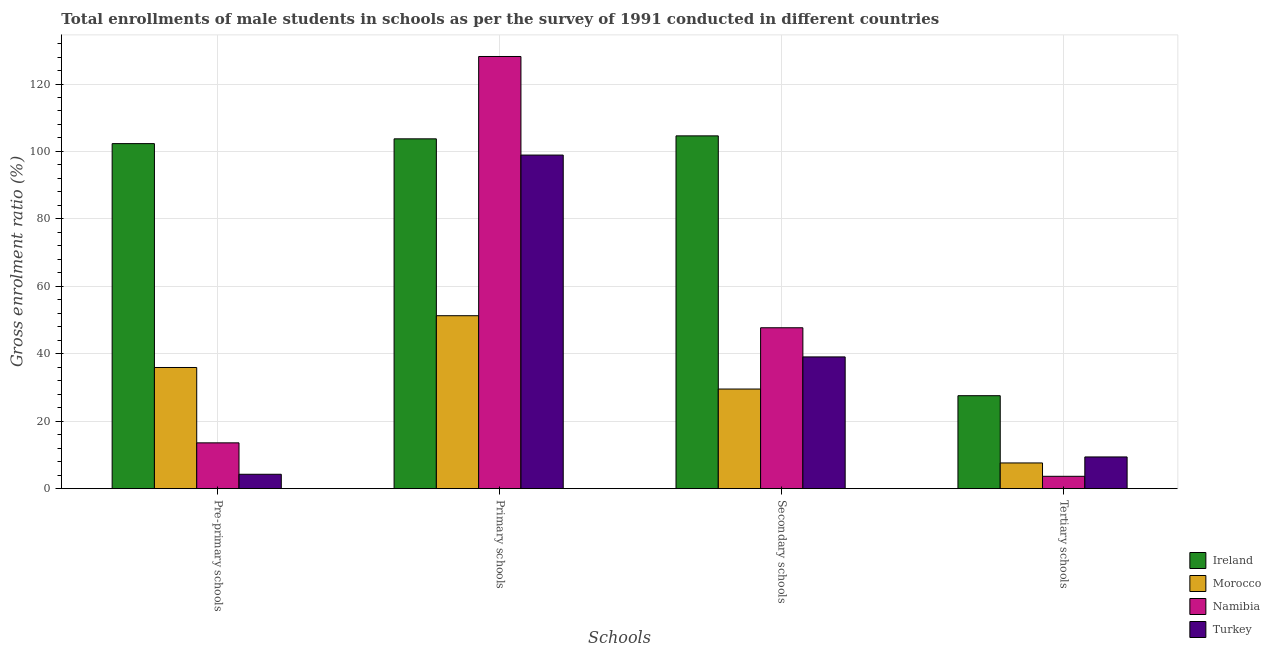How many groups of bars are there?
Your answer should be compact. 4. Are the number of bars per tick equal to the number of legend labels?
Provide a succinct answer. Yes. Are the number of bars on each tick of the X-axis equal?
Provide a succinct answer. Yes. How many bars are there on the 4th tick from the left?
Offer a very short reply. 4. How many bars are there on the 1st tick from the right?
Give a very brief answer. 4. What is the label of the 1st group of bars from the left?
Your response must be concise. Pre-primary schools. What is the gross enrolment ratio(male) in primary schools in Morocco?
Offer a terse response. 51.29. Across all countries, what is the maximum gross enrolment ratio(male) in tertiary schools?
Your response must be concise. 27.57. Across all countries, what is the minimum gross enrolment ratio(male) in secondary schools?
Give a very brief answer. 29.54. In which country was the gross enrolment ratio(male) in secondary schools maximum?
Offer a terse response. Ireland. In which country was the gross enrolment ratio(male) in tertiary schools minimum?
Provide a short and direct response. Namibia. What is the total gross enrolment ratio(male) in primary schools in the graph?
Offer a very short reply. 382.12. What is the difference between the gross enrolment ratio(male) in secondary schools in Morocco and that in Turkey?
Provide a succinct answer. -9.53. What is the difference between the gross enrolment ratio(male) in primary schools in Namibia and the gross enrolment ratio(male) in pre-primary schools in Turkey?
Your response must be concise. 123.89. What is the average gross enrolment ratio(male) in primary schools per country?
Ensure brevity in your answer.  95.53. What is the difference between the gross enrolment ratio(male) in pre-primary schools and gross enrolment ratio(male) in primary schools in Turkey?
Provide a succinct answer. -94.66. What is the ratio of the gross enrolment ratio(male) in tertiary schools in Namibia to that in Turkey?
Your answer should be compact. 0.39. Is the gross enrolment ratio(male) in tertiary schools in Namibia less than that in Ireland?
Your answer should be very brief. Yes. What is the difference between the highest and the second highest gross enrolment ratio(male) in tertiary schools?
Your answer should be compact. 18.16. What is the difference between the highest and the lowest gross enrolment ratio(male) in pre-primary schools?
Give a very brief answer. 98.05. What does the 1st bar from the left in Secondary schools represents?
Provide a succinct answer. Ireland. Is it the case that in every country, the sum of the gross enrolment ratio(male) in pre-primary schools and gross enrolment ratio(male) in primary schools is greater than the gross enrolment ratio(male) in secondary schools?
Your answer should be very brief. Yes. How many bars are there?
Offer a terse response. 16. Are all the bars in the graph horizontal?
Keep it short and to the point. No. How many countries are there in the graph?
Provide a short and direct response. 4. What is the difference between two consecutive major ticks on the Y-axis?
Keep it short and to the point. 20. Are the values on the major ticks of Y-axis written in scientific E-notation?
Offer a terse response. No. Does the graph contain any zero values?
Your answer should be very brief. No. Where does the legend appear in the graph?
Ensure brevity in your answer.  Bottom right. How are the legend labels stacked?
Your answer should be compact. Vertical. What is the title of the graph?
Provide a succinct answer. Total enrollments of male students in schools as per the survey of 1991 conducted in different countries. What is the label or title of the X-axis?
Your answer should be very brief. Schools. What is the Gross enrolment ratio (%) in Ireland in Pre-primary schools?
Offer a terse response. 102.32. What is the Gross enrolment ratio (%) in Morocco in Pre-primary schools?
Provide a succinct answer. 35.94. What is the Gross enrolment ratio (%) of Namibia in Pre-primary schools?
Give a very brief answer. 13.59. What is the Gross enrolment ratio (%) of Turkey in Pre-primary schools?
Provide a succinct answer. 4.27. What is the Gross enrolment ratio (%) in Ireland in Primary schools?
Provide a short and direct response. 103.74. What is the Gross enrolment ratio (%) of Morocco in Primary schools?
Offer a terse response. 51.29. What is the Gross enrolment ratio (%) in Namibia in Primary schools?
Provide a short and direct response. 128.16. What is the Gross enrolment ratio (%) in Turkey in Primary schools?
Provide a succinct answer. 98.93. What is the Gross enrolment ratio (%) of Ireland in Secondary schools?
Give a very brief answer. 104.62. What is the Gross enrolment ratio (%) of Morocco in Secondary schools?
Your answer should be very brief. 29.54. What is the Gross enrolment ratio (%) of Namibia in Secondary schools?
Keep it short and to the point. 47.72. What is the Gross enrolment ratio (%) in Turkey in Secondary schools?
Offer a very short reply. 39.07. What is the Gross enrolment ratio (%) in Ireland in Tertiary schools?
Offer a terse response. 27.57. What is the Gross enrolment ratio (%) in Morocco in Tertiary schools?
Give a very brief answer. 7.63. What is the Gross enrolment ratio (%) of Namibia in Tertiary schools?
Offer a very short reply. 3.67. What is the Gross enrolment ratio (%) of Turkey in Tertiary schools?
Provide a succinct answer. 9.41. Across all Schools, what is the maximum Gross enrolment ratio (%) in Ireland?
Offer a terse response. 104.62. Across all Schools, what is the maximum Gross enrolment ratio (%) in Morocco?
Ensure brevity in your answer.  51.29. Across all Schools, what is the maximum Gross enrolment ratio (%) in Namibia?
Give a very brief answer. 128.16. Across all Schools, what is the maximum Gross enrolment ratio (%) of Turkey?
Your response must be concise. 98.93. Across all Schools, what is the minimum Gross enrolment ratio (%) in Ireland?
Your answer should be very brief. 27.57. Across all Schools, what is the minimum Gross enrolment ratio (%) in Morocco?
Offer a terse response. 7.63. Across all Schools, what is the minimum Gross enrolment ratio (%) of Namibia?
Give a very brief answer. 3.67. Across all Schools, what is the minimum Gross enrolment ratio (%) in Turkey?
Provide a short and direct response. 4.27. What is the total Gross enrolment ratio (%) of Ireland in the graph?
Make the answer very short. 338.26. What is the total Gross enrolment ratio (%) in Morocco in the graph?
Provide a succinct answer. 124.4. What is the total Gross enrolment ratio (%) in Namibia in the graph?
Keep it short and to the point. 193.14. What is the total Gross enrolment ratio (%) in Turkey in the graph?
Make the answer very short. 151.68. What is the difference between the Gross enrolment ratio (%) of Ireland in Pre-primary schools and that in Primary schools?
Your answer should be very brief. -1.42. What is the difference between the Gross enrolment ratio (%) in Morocco in Pre-primary schools and that in Primary schools?
Give a very brief answer. -15.35. What is the difference between the Gross enrolment ratio (%) of Namibia in Pre-primary schools and that in Primary schools?
Give a very brief answer. -114.58. What is the difference between the Gross enrolment ratio (%) of Turkey in Pre-primary schools and that in Primary schools?
Your answer should be compact. -94.66. What is the difference between the Gross enrolment ratio (%) of Ireland in Pre-primary schools and that in Secondary schools?
Make the answer very short. -2.3. What is the difference between the Gross enrolment ratio (%) in Morocco in Pre-primary schools and that in Secondary schools?
Offer a very short reply. 6.39. What is the difference between the Gross enrolment ratio (%) in Namibia in Pre-primary schools and that in Secondary schools?
Your answer should be compact. -34.13. What is the difference between the Gross enrolment ratio (%) of Turkey in Pre-primary schools and that in Secondary schools?
Your answer should be very brief. -34.8. What is the difference between the Gross enrolment ratio (%) of Ireland in Pre-primary schools and that in Tertiary schools?
Offer a very short reply. 74.75. What is the difference between the Gross enrolment ratio (%) in Morocco in Pre-primary schools and that in Tertiary schools?
Offer a terse response. 28.31. What is the difference between the Gross enrolment ratio (%) in Namibia in Pre-primary schools and that in Tertiary schools?
Make the answer very short. 9.92. What is the difference between the Gross enrolment ratio (%) in Turkey in Pre-primary schools and that in Tertiary schools?
Your answer should be very brief. -5.14. What is the difference between the Gross enrolment ratio (%) of Ireland in Primary schools and that in Secondary schools?
Make the answer very short. -0.88. What is the difference between the Gross enrolment ratio (%) in Morocco in Primary schools and that in Secondary schools?
Your response must be concise. 21.74. What is the difference between the Gross enrolment ratio (%) in Namibia in Primary schools and that in Secondary schools?
Keep it short and to the point. 80.45. What is the difference between the Gross enrolment ratio (%) in Turkey in Primary schools and that in Secondary schools?
Make the answer very short. 59.85. What is the difference between the Gross enrolment ratio (%) in Ireland in Primary schools and that in Tertiary schools?
Ensure brevity in your answer.  76.17. What is the difference between the Gross enrolment ratio (%) in Morocco in Primary schools and that in Tertiary schools?
Provide a short and direct response. 43.66. What is the difference between the Gross enrolment ratio (%) of Namibia in Primary schools and that in Tertiary schools?
Give a very brief answer. 124.5. What is the difference between the Gross enrolment ratio (%) of Turkey in Primary schools and that in Tertiary schools?
Provide a short and direct response. 89.52. What is the difference between the Gross enrolment ratio (%) of Ireland in Secondary schools and that in Tertiary schools?
Make the answer very short. 77.05. What is the difference between the Gross enrolment ratio (%) of Morocco in Secondary schools and that in Tertiary schools?
Your answer should be very brief. 21.92. What is the difference between the Gross enrolment ratio (%) of Namibia in Secondary schools and that in Tertiary schools?
Your response must be concise. 44.05. What is the difference between the Gross enrolment ratio (%) of Turkey in Secondary schools and that in Tertiary schools?
Your response must be concise. 29.66. What is the difference between the Gross enrolment ratio (%) of Ireland in Pre-primary schools and the Gross enrolment ratio (%) of Morocco in Primary schools?
Offer a terse response. 51.03. What is the difference between the Gross enrolment ratio (%) in Ireland in Pre-primary schools and the Gross enrolment ratio (%) in Namibia in Primary schools?
Provide a short and direct response. -25.84. What is the difference between the Gross enrolment ratio (%) of Ireland in Pre-primary schools and the Gross enrolment ratio (%) of Turkey in Primary schools?
Ensure brevity in your answer.  3.4. What is the difference between the Gross enrolment ratio (%) in Morocco in Pre-primary schools and the Gross enrolment ratio (%) in Namibia in Primary schools?
Your answer should be compact. -92.22. What is the difference between the Gross enrolment ratio (%) of Morocco in Pre-primary schools and the Gross enrolment ratio (%) of Turkey in Primary schools?
Your response must be concise. -62.99. What is the difference between the Gross enrolment ratio (%) in Namibia in Pre-primary schools and the Gross enrolment ratio (%) in Turkey in Primary schools?
Offer a very short reply. -85.34. What is the difference between the Gross enrolment ratio (%) of Ireland in Pre-primary schools and the Gross enrolment ratio (%) of Morocco in Secondary schools?
Ensure brevity in your answer.  72.78. What is the difference between the Gross enrolment ratio (%) in Ireland in Pre-primary schools and the Gross enrolment ratio (%) in Namibia in Secondary schools?
Give a very brief answer. 54.61. What is the difference between the Gross enrolment ratio (%) in Ireland in Pre-primary schools and the Gross enrolment ratio (%) in Turkey in Secondary schools?
Provide a succinct answer. 63.25. What is the difference between the Gross enrolment ratio (%) of Morocco in Pre-primary schools and the Gross enrolment ratio (%) of Namibia in Secondary schools?
Give a very brief answer. -11.78. What is the difference between the Gross enrolment ratio (%) of Morocco in Pre-primary schools and the Gross enrolment ratio (%) of Turkey in Secondary schools?
Make the answer very short. -3.14. What is the difference between the Gross enrolment ratio (%) of Namibia in Pre-primary schools and the Gross enrolment ratio (%) of Turkey in Secondary schools?
Provide a succinct answer. -25.49. What is the difference between the Gross enrolment ratio (%) in Ireland in Pre-primary schools and the Gross enrolment ratio (%) in Morocco in Tertiary schools?
Make the answer very short. 94.69. What is the difference between the Gross enrolment ratio (%) of Ireland in Pre-primary schools and the Gross enrolment ratio (%) of Namibia in Tertiary schools?
Keep it short and to the point. 98.66. What is the difference between the Gross enrolment ratio (%) of Ireland in Pre-primary schools and the Gross enrolment ratio (%) of Turkey in Tertiary schools?
Your answer should be compact. 92.91. What is the difference between the Gross enrolment ratio (%) of Morocco in Pre-primary schools and the Gross enrolment ratio (%) of Namibia in Tertiary schools?
Your answer should be very brief. 32.27. What is the difference between the Gross enrolment ratio (%) of Morocco in Pre-primary schools and the Gross enrolment ratio (%) of Turkey in Tertiary schools?
Provide a succinct answer. 26.53. What is the difference between the Gross enrolment ratio (%) in Namibia in Pre-primary schools and the Gross enrolment ratio (%) in Turkey in Tertiary schools?
Ensure brevity in your answer.  4.18. What is the difference between the Gross enrolment ratio (%) of Ireland in Primary schools and the Gross enrolment ratio (%) of Morocco in Secondary schools?
Keep it short and to the point. 74.2. What is the difference between the Gross enrolment ratio (%) of Ireland in Primary schools and the Gross enrolment ratio (%) of Namibia in Secondary schools?
Provide a succinct answer. 56.02. What is the difference between the Gross enrolment ratio (%) of Ireland in Primary schools and the Gross enrolment ratio (%) of Turkey in Secondary schools?
Give a very brief answer. 64.67. What is the difference between the Gross enrolment ratio (%) in Morocco in Primary schools and the Gross enrolment ratio (%) in Namibia in Secondary schools?
Make the answer very short. 3.57. What is the difference between the Gross enrolment ratio (%) of Morocco in Primary schools and the Gross enrolment ratio (%) of Turkey in Secondary schools?
Your answer should be very brief. 12.22. What is the difference between the Gross enrolment ratio (%) in Namibia in Primary schools and the Gross enrolment ratio (%) in Turkey in Secondary schools?
Your answer should be very brief. 89.09. What is the difference between the Gross enrolment ratio (%) in Ireland in Primary schools and the Gross enrolment ratio (%) in Morocco in Tertiary schools?
Offer a very short reply. 96.11. What is the difference between the Gross enrolment ratio (%) of Ireland in Primary schools and the Gross enrolment ratio (%) of Namibia in Tertiary schools?
Make the answer very short. 100.08. What is the difference between the Gross enrolment ratio (%) of Ireland in Primary schools and the Gross enrolment ratio (%) of Turkey in Tertiary schools?
Your response must be concise. 94.33. What is the difference between the Gross enrolment ratio (%) in Morocco in Primary schools and the Gross enrolment ratio (%) in Namibia in Tertiary schools?
Offer a terse response. 47.62. What is the difference between the Gross enrolment ratio (%) in Morocco in Primary schools and the Gross enrolment ratio (%) in Turkey in Tertiary schools?
Provide a short and direct response. 41.88. What is the difference between the Gross enrolment ratio (%) of Namibia in Primary schools and the Gross enrolment ratio (%) of Turkey in Tertiary schools?
Your response must be concise. 118.75. What is the difference between the Gross enrolment ratio (%) in Ireland in Secondary schools and the Gross enrolment ratio (%) in Morocco in Tertiary schools?
Ensure brevity in your answer.  96.99. What is the difference between the Gross enrolment ratio (%) of Ireland in Secondary schools and the Gross enrolment ratio (%) of Namibia in Tertiary schools?
Offer a very short reply. 100.96. What is the difference between the Gross enrolment ratio (%) in Ireland in Secondary schools and the Gross enrolment ratio (%) in Turkey in Tertiary schools?
Keep it short and to the point. 95.21. What is the difference between the Gross enrolment ratio (%) in Morocco in Secondary schools and the Gross enrolment ratio (%) in Namibia in Tertiary schools?
Make the answer very short. 25.88. What is the difference between the Gross enrolment ratio (%) of Morocco in Secondary schools and the Gross enrolment ratio (%) of Turkey in Tertiary schools?
Your answer should be very brief. 20.14. What is the difference between the Gross enrolment ratio (%) in Namibia in Secondary schools and the Gross enrolment ratio (%) in Turkey in Tertiary schools?
Give a very brief answer. 38.31. What is the average Gross enrolment ratio (%) of Ireland per Schools?
Keep it short and to the point. 84.57. What is the average Gross enrolment ratio (%) of Morocco per Schools?
Make the answer very short. 31.1. What is the average Gross enrolment ratio (%) of Namibia per Schools?
Offer a terse response. 48.28. What is the average Gross enrolment ratio (%) of Turkey per Schools?
Provide a short and direct response. 37.92. What is the difference between the Gross enrolment ratio (%) of Ireland and Gross enrolment ratio (%) of Morocco in Pre-primary schools?
Your answer should be very brief. 66.39. What is the difference between the Gross enrolment ratio (%) in Ireland and Gross enrolment ratio (%) in Namibia in Pre-primary schools?
Your answer should be compact. 88.74. What is the difference between the Gross enrolment ratio (%) in Ireland and Gross enrolment ratio (%) in Turkey in Pre-primary schools?
Ensure brevity in your answer.  98.05. What is the difference between the Gross enrolment ratio (%) of Morocco and Gross enrolment ratio (%) of Namibia in Pre-primary schools?
Your response must be concise. 22.35. What is the difference between the Gross enrolment ratio (%) in Morocco and Gross enrolment ratio (%) in Turkey in Pre-primary schools?
Offer a very short reply. 31.67. What is the difference between the Gross enrolment ratio (%) of Namibia and Gross enrolment ratio (%) of Turkey in Pre-primary schools?
Provide a succinct answer. 9.32. What is the difference between the Gross enrolment ratio (%) in Ireland and Gross enrolment ratio (%) in Morocco in Primary schools?
Your answer should be very brief. 52.45. What is the difference between the Gross enrolment ratio (%) in Ireland and Gross enrolment ratio (%) in Namibia in Primary schools?
Provide a short and direct response. -24.42. What is the difference between the Gross enrolment ratio (%) in Ireland and Gross enrolment ratio (%) in Turkey in Primary schools?
Provide a short and direct response. 4.82. What is the difference between the Gross enrolment ratio (%) in Morocco and Gross enrolment ratio (%) in Namibia in Primary schools?
Your answer should be very brief. -76.87. What is the difference between the Gross enrolment ratio (%) of Morocco and Gross enrolment ratio (%) of Turkey in Primary schools?
Make the answer very short. -47.64. What is the difference between the Gross enrolment ratio (%) of Namibia and Gross enrolment ratio (%) of Turkey in Primary schools?
Ensure brevity in your answer.  29.24. What is the difference between the Gross enrolment ratio (%) in Ireland and Gross enrolment ratio (%) in Morocco in Secondary schools?
Your answer should be very brief. 75.08. What is the difference between the Gross enrolment ratio (%) of Ireland and Gross enrolment ratio (%) of Namibia in Secondary schools?
Your response must be concise. 56.91. What is the difference between the Gross enrolment ratio (%) in Ireland and Gross enrolment ratio (%) in Turkey in Secondary schools?
Make the answer very short. 65.55. What is the difference between the Gross enrolment ratio (%) of Morocco and Gross enrolment ratio (%) of Namibia in Secondary schools?
Your response must be concise. -18.17. What is the difference between the Gross enrolment ratio (%) of Morocco and Gross enrolment ratio (%) of Turkey in Secondary schools?
Offer a terse response. -9.53. What is the difference between the Gross enrolment ratio (%) of Namibia and Gross enrolment ratio (%) of Turkey in Secondary schools?
Give a very brief answer. 8.64. What is the difference between the Gross enrolment ratio (%) in Ireland and Gross enrolment ratio (%) in Morocco in Tertiary schools?
Your response must be concise. 19.95. What is the difference between the Gross enrolment ratio (%) in Ireland and Gross enrolment ratio (%) in Namibia in Tertiary schools?
Offer a terse response. 23.91. What is the difference between the Gross enrolment ratio (%) in Ireland and Gross enrolment ratio (%) in Turkey in Tertiary schools?
Your response must be concise. 18.16. What is the difference between the Gross enrolment ratio (%) in Morocco and Gross enrolment ratio (%) in Namibia in Tertiary schools?
Provide a short and direct response. 3.96. What is the difference between the Gross enrolment ratio (%) in Morocco and Gross enrolment ratio (%) in Turkey in Tertiary schools?
Your response must be concise. -1.78. What is the difference between the Gross enrolment ratio (%) in Namibia and Gross enrolment ratio (%) in Turkey in Tertiary schools?
Provide a succinct answer. -5.74. What is the ratio of the Gross enrolment ratio (%) of Ireland in Pre-primary schools to that in Primary schools?
Keep it short and to the point. 0.99. What is the ratio of the Gross enrolment ratio (%) of Morocco in Pre-primary schools to that in Primary schools?
Provide a succinct answer. 0.7. What is the ratio of the Gross enrolment ratio (%) of Namibia in Pre-primary schools to that in Primary schools?
Ensure brevity in your answer.  0.11. What is the ratio of the Gross enrolment ratio (%) of Turkey in Pre-primary schools to that in Primary schools?
Give a very brief answer. 0.04. What is the ratio of the Gross enrolment ratio (%) in Ireland in Pre-primary schools to that in Secondary schools?
Offer a terse response. 0.98. What is the ratio of the Gross enrolment ratio (%) in Morocco in Pre-primary schools to that in Secondary schools?
Provide a short and direct response. 1.22. What is the ratio of the Gross enrolment ratio (%) in Namibia in Pre-primary schools to that in Secondary schools?
Provide a succinct answer. 0.28. What is the ratio of the Gross enrolment ratio (%) of Turkey in Pre-primary schools to that in Secondary schools?
Make the answer very short. 0.11. What is the ratio of the Gross enrolment ratio (%) in Ireland in Pre-primary schools to that in Tertiary schools?
Offer a terse response. 3.71. What is the ratio of the Gross enrolment ratio (%) of Morocco in Pre-primary schools to that in Tertiary schools?
Offer a very short reply. 4.71. What is the ratio of the Gross enrolment ratio (%) of Namibia in Pre-primary schools to that in Tertiary schools?
Offer a terse response. 3.71. What is the ratio of the Gross enrolment ratio (%) of Turkey in Pre-primary schools to that in Tertiary schools?
Offer a terse response. 0.45. What is the ratio of the Gross enrolment ratio (%) in Ireland in Primary schools to that in Secondary schools?
Ensure brevity in your answer.  0.99. What is the ratio of the Gross enrolment ratio (%) of Morocco in Primary schools to that in Secondary schools?
Provide a succinct answer. 1.74. What is the ratio of the Gross enrolment ratio (%) in Namibia in Primary schools to that in Secondary schools?
Your response must be concise. 2.69. What is the ratio of the Gross enrolment ratio (%) of Turkey in Primary schools to that in Secondary schools?
Your response must be concise. 2.53. What is the ratio of the Gross enrolment ratio (%) of Ireland in Primary schools to that in Tertiary schools?
Offer a terse response. 3.76. What is the ratio of the Gross enrolment ratio (%) in Morocco in Primary schools to that in Tertiary schools?
Offer a terse response. 6.72. What is the ratio of the Gross enrolment ratio (%) in Namibia in Primary schools to that in Tertiary schools?
Provide a succinct answer. 34.95. What is the ratio of the Gross enrolment ratio (%) of Turkey in Primary schools to that in Tertiary schools?
Offer a very short reply. 10.51. What is the ratio of the Gross enrolment ratio (%) in Ireland in Secondary schools to that in Tertiary schools?
Provide a short and direct response. 3.79. What is the ratio of the Gross enrolment ratio (%) in Morocco in Secondary schools to that in Tertiary schools?
Your answer should be compact. 3.87. What is the ratio of the Gross enrolment ratio (%) of Namibia in Secondary schools to that in Tertiary schools?
Give a very brief answer. 13.01. What is the ratio of the Gross enrolment ratio (%) in Turkey in Secondary schools to that in Tertiary schools?
Offer a very short reply. 4.15. What is the difference between the highest and the second highest Gross enrolment ratio (%) of Ireland?
Make the answer very short. 0.88. What is the difference between the highest and the second highest Gross enrolment ratio (%) of Morocco?
Your answer should be compact. 15.35. What is the difference between the highest and the second highest Gross enrolment ratio (%) of Namibia?
Provide a succinct answer. 80.45. What is the difference between the highest and the second highest Gross enrolment ratio (%) in Turkey?
Your answer should be compact. 59.85. What is the difference between the highest and the lowest Gross enrolment ratio (%) of Ireland?
Your response must be concise. 77.05. What is the difference between the highest and the lowest Gross enrolment ratio (%) in Morocco?
Ensure brevity in your answer.  43.66. What is the difference between the highest and the lowest Gross enrolment ratio (%) of Namibia?
Make the answer very short. 124.5. What is the difference between the highest and the lowest Gross enrolment ratio (%) of Turkey?
Offer a terse response. 94.66. 